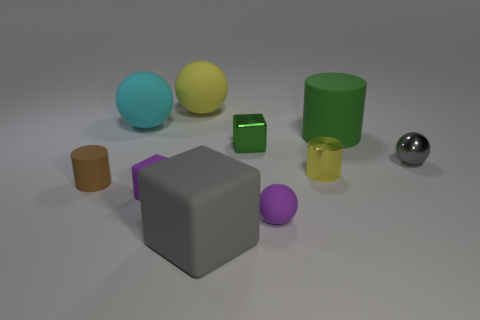The rubber sphere that is the same color as the small metal cylinder is what size?
Offer a terse response. Large. Is there any other thing of the same color as the large cylinder?
Your answer should be compact. Yes. There is a cyan rubber thing that is left of the small metallic cylinder; what is its size?
Give a very brief answer. Large. Is the number of gray shiny cylinders greater than the number of yellow shiny cylinders?
Offer a very short reply. No. What material is the yellow cylinder?
Give a very brief answer. Metal. How many other objects are there of the same material as the large cyan sphere?
Offer a terse response. 6. How many big blue matte cubes are there?
Make the answer very short. 0. What material is the small purple object that is the same shape as the green shiny object?
Make the answer very short. Rubber. Is the material of the sphere that is right of the tiny purple rubber ball the same as the green cube?
Provide a succinct answer. Yes. Is the number of metallic blocks left of the big gray cube greater than the number of metal cubes that are behind the tiny green thing?
Offer a terse response. No. 